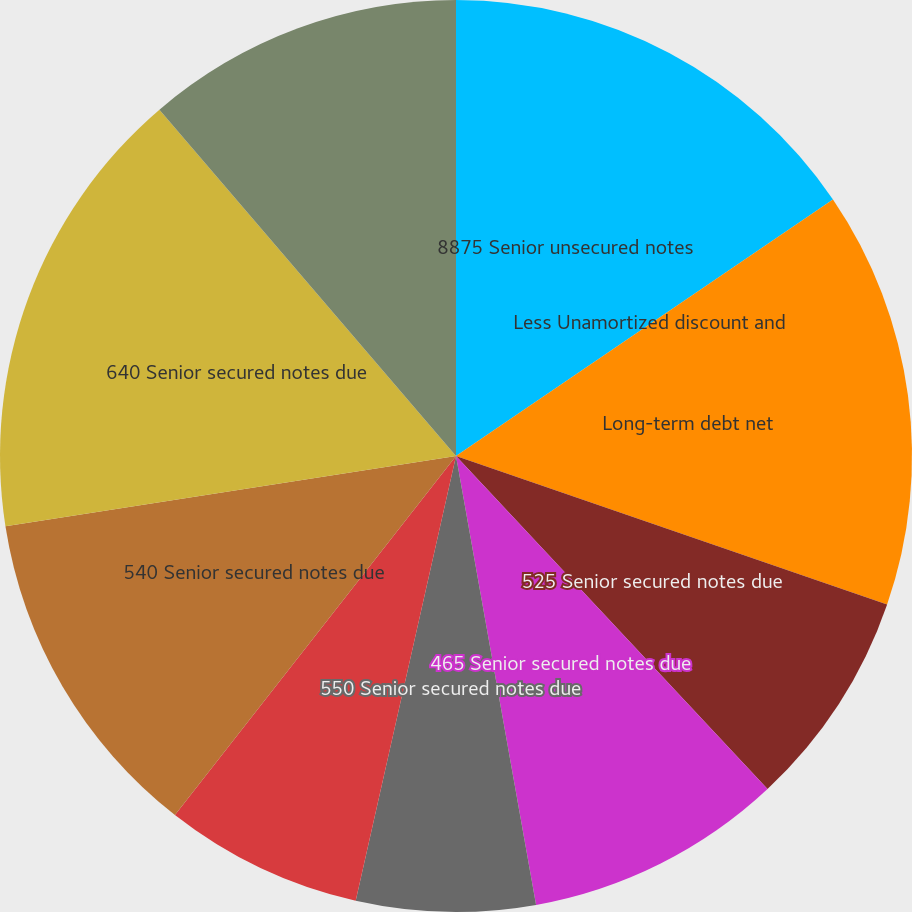<chart> <loc_0><loc_0><loc_500><loc_500><pie_chart><fcel>8875 Senior unsecured notes<fcel>Less Unamortized discount and<fcel>Long-term debt net<fcel>525 Senior secured notes due<fcel>465 Senior secured notes due<fcel>550 Senior secured notes due<fcel>475 Senior secured notes due<fcel>540 Senior secured notes due<fcel>640 Senior secured notes due<fcel>600 Senior secured notes due<nl><fcel>15.49%<fcel>0.0%<fcel>14.79%<fcel>7.75%<fcel>9.16%<fcel>6.34%<fcel>7.04%<fcel>11.97%<fcel>16.19%<fcel>11.27%<nl></chart> 